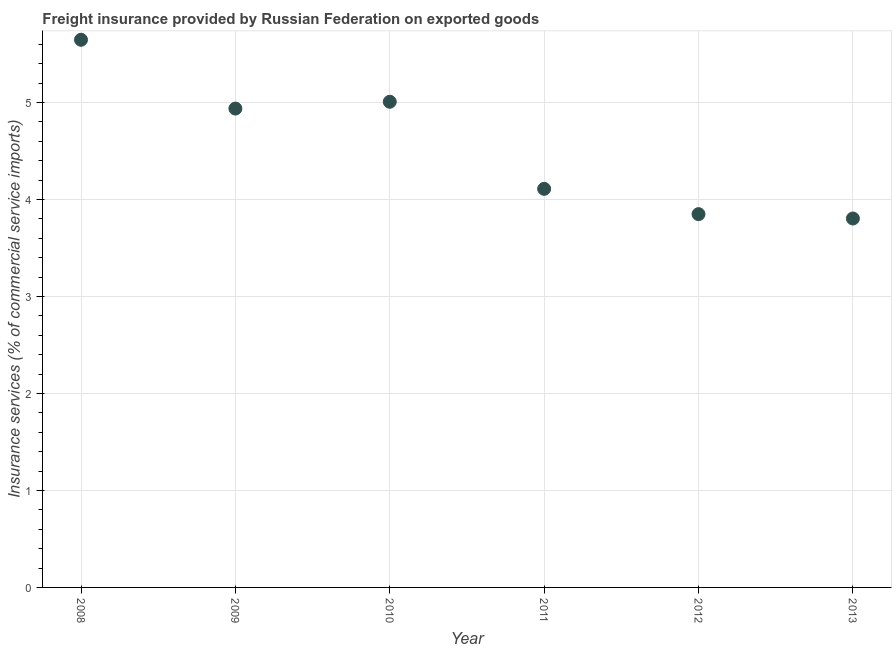What is the freight insurance in 2013?
Ensure brevity in your answer.  3.8. Across all years, what is the maximum freight insurance?
Your answer should be very brief. 5.65. Across all years, what is the minimum freight insurance?
Make the answer very short. 3.8. In which year was the freight insurance maximum?
Your response must be concise. 2008. In which year was the freight insurance minimum?
Provide a succinct answer. 2013. What is the sum of the freight insurance?
Your answer should be compact. 27.36. What is the difference between the freight insurance in 2009 and 2012?
Offer a terse response. 1.09. What is the average freight insurance per year?
Provide a short and direct response. 4.56. What is the median freight insurance?
Your answer should be compact. 4.52. What is the ratio of the freight insurance in 2009 to that in 2010?
Keep it short and to the point. 0.99. Is the freight insurance in 2011 less than that in 2013?
Your answer should be compact. No. What is the difference between the highest and the second highest freight insurance?
Provide a short and direct response. 0.64. Is the sum of the freight insurance in 2010 and 2011 greater than the maximum freight insurance across all years?
Keep it short and to the point. Yes. What is the difference between the highest and the lowest freight insurance?
Your answer should be very brief. 1.84. In how many years, is the freight insurance greater than the average freight insurance taken over all years?
Make the answer very short. 3. Does the freight insurance monotonically increase over the years?
Your answer should be very brief. No. What is the difference between two consecutive major ticks on the Y-axis?
Offer a very short reply. 1. Does the graph contain grids?
Offer a very short reply. Yes. What is the title of the graph?
Ensure brevity in your answer.  Freight insurance provided by Russian Federation on exported goods . What is the label or title of the Y-axis?
Offer a very short reply. Insurance services (% of commercial service imports). What is the Insurance services (% of commercial service imports) in 2008?
Make the answer very short. 5.65. What is the Insurance services (% of commercial service imports) in 2009?
Provide a short and direct response. 4.94. What is the Insurance services (% of commercial service imports) in 2010?
Your answer should be compact. 5.01. What is the Insurance services (% of commercial service imports) in 2011?
Keep it short and to the point. 4.11. What is the Insurance services (% of commercial service imports) in 2012?
Make the answer very short. 3.85. What is the Insurance services (% of commercial service imports) in 2013?
Offer a very short reply. 3.8. What is the difference between the Insurance services (% of commercial service imports) in 2008 and 2009?
Provide a short and direct response. 0.71. What is the difference between the Insurance services (% of commercial service imports) in 2008 and 2010?
Ensure brevity in your answer.  0.64. What is the difference between the Insurance services (% of commercial service imports) in 2008 and 2011?
Provide a succinct answer. 1.54. What is the difference between the Insurance services (% of commercial service imports) in 2008 and 2012?
Provide a succinct answer. 1.8. What is the difference between the Insurance services (% of commercial service imports) in 2008 and 2013?
Make the answer very short. 1.84. What is the difference between the Insurance services (% of commercial service imports) in 2009 and 2010?
Keep it short and to the point. -0.07. What is the difference between the Insurance services (% of commercial service imports) in 2009 and 2011?
Ensure brevity in your answer.  0.83. What is the difference between the Insurance services (% of commercial service imports) in 2009 and 2012?
Your response must be concise. 1.09. What is the difference between the Insurance services (% of commercial service imports) in 2009 and 2013?
Provide a short and direct response. 1.13. What is the difference between the Insurance services (% of commercial service imports) in 2010 and 2011?
Offer a terse response. 0.9. What is the difference between the Insurance services (% of commercial service imports) in 2010 and 2012?
Your answer should be compact. 1.16. What is the difference between the Insurance services (% of commercial service imports) in 2010 and 2013?
Offer a very short reply. 1.2. What is the difference between the Insurance services (% of commercial service imports) in 2011 and 2012?
Offer a very short reply. 0.26. What is the difference between the Insurance services (% of commercial service imports) in 2011 and 2013?
Your answer should be very brief. 0.31. What is the difference between the Insurance services (% of commercial service imports) in 2012 and 2013?
Offer a very short reply. 0.04. What is the ratio of the Insurance services (% of commercial service imports) in 2008 to that in 2009?
Provide a succinct answer. 1.14. What is the ratio of the Insurance services (% of commercial service imports) in 2008 to that in 2010?
Ensure brevity in your answer.  1.13. What is the ratio of the Insurance services (% of commercial service imports) in 2008 to that in 2011?
Provide a short and direct response. 1.37. What is the ratio of the Insurance services (% of commercial service imports) in 2008 to that in 2012?
Provide a succinct answer. 1.47. What is the ratio of the Insurance services (% of commercial service imports) in 2008 to that in 2013?
Your answer should be compact. 1.48. What is the ratio of the Insurance services (% of commercial service imports) in 2009 to that in 2010?
Offer a very short reply. 0.99. What is the ratio of the Insurance services (% of commercial service imports) in 2009 to that in 2011?
Your answer should be compact. 1.2. What is the ratio of the Insurance services (% of commercial service imports) in 2009 to that in 2012?
Your answer should be compact. 1.28. What is the ratio of the Insurance services (% of commercial service imports) in 2009 to that in 2013?
Offer a very short reply. 1.3. What is the ratio of the Insurance services (% of commercial service imports) in 2010 to that in 2011?
Your response must be concise. 1.22. What is the ratio of the Insurance services (% of commercial service imports) in 2010 to that in 2012?
Your answer should be compact. 1.3. What is the ratio of the Insurance services (% of commercial service imports) in 2010 to that in 2013?
Your response must be concise. 1.32. What is the ratio of the Insurance services (% of commercial service imports) in 2011 to that in 2012?
Your answer should be compact. 1.07. What is the ratio of the Insurance services (% of commercial service imports) in 2011 to that in 2013?
Give a very brief answer. 1.08. What is the ratio of the Insurance services (% of commercial service imports) in 2012 to that in 2013?
Your answer should be compact. 1.01. 